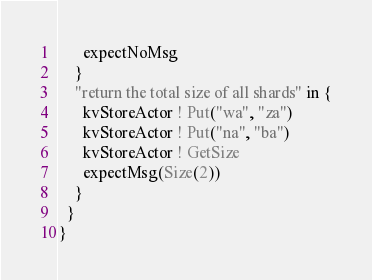Convert code to text. <code><loc_0><loc_0><loc_500><loc_500><_Scala_>      expectNoMsg
    }
    "return the total size of all shards" in {
      kvStoreActor ! Put("wa", "za")
      kvStoreActor ! Put("na", "ba")
      kvStoreActor ! GetSize
      expectMsg(Size(2))
    }
  }
}
</code> 